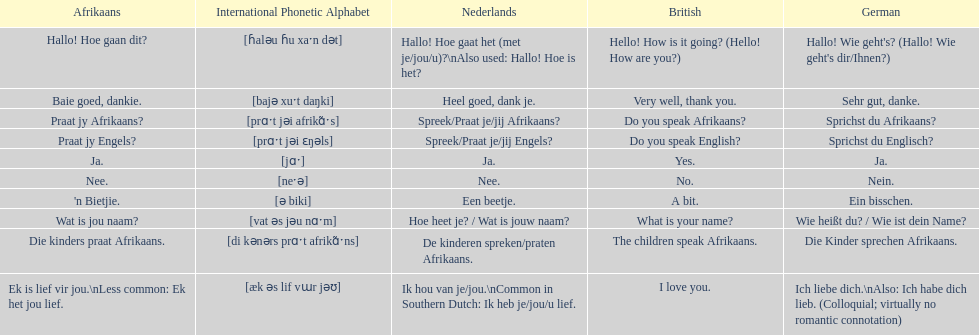Translate the following into english: 'n bietjie. A bit. 